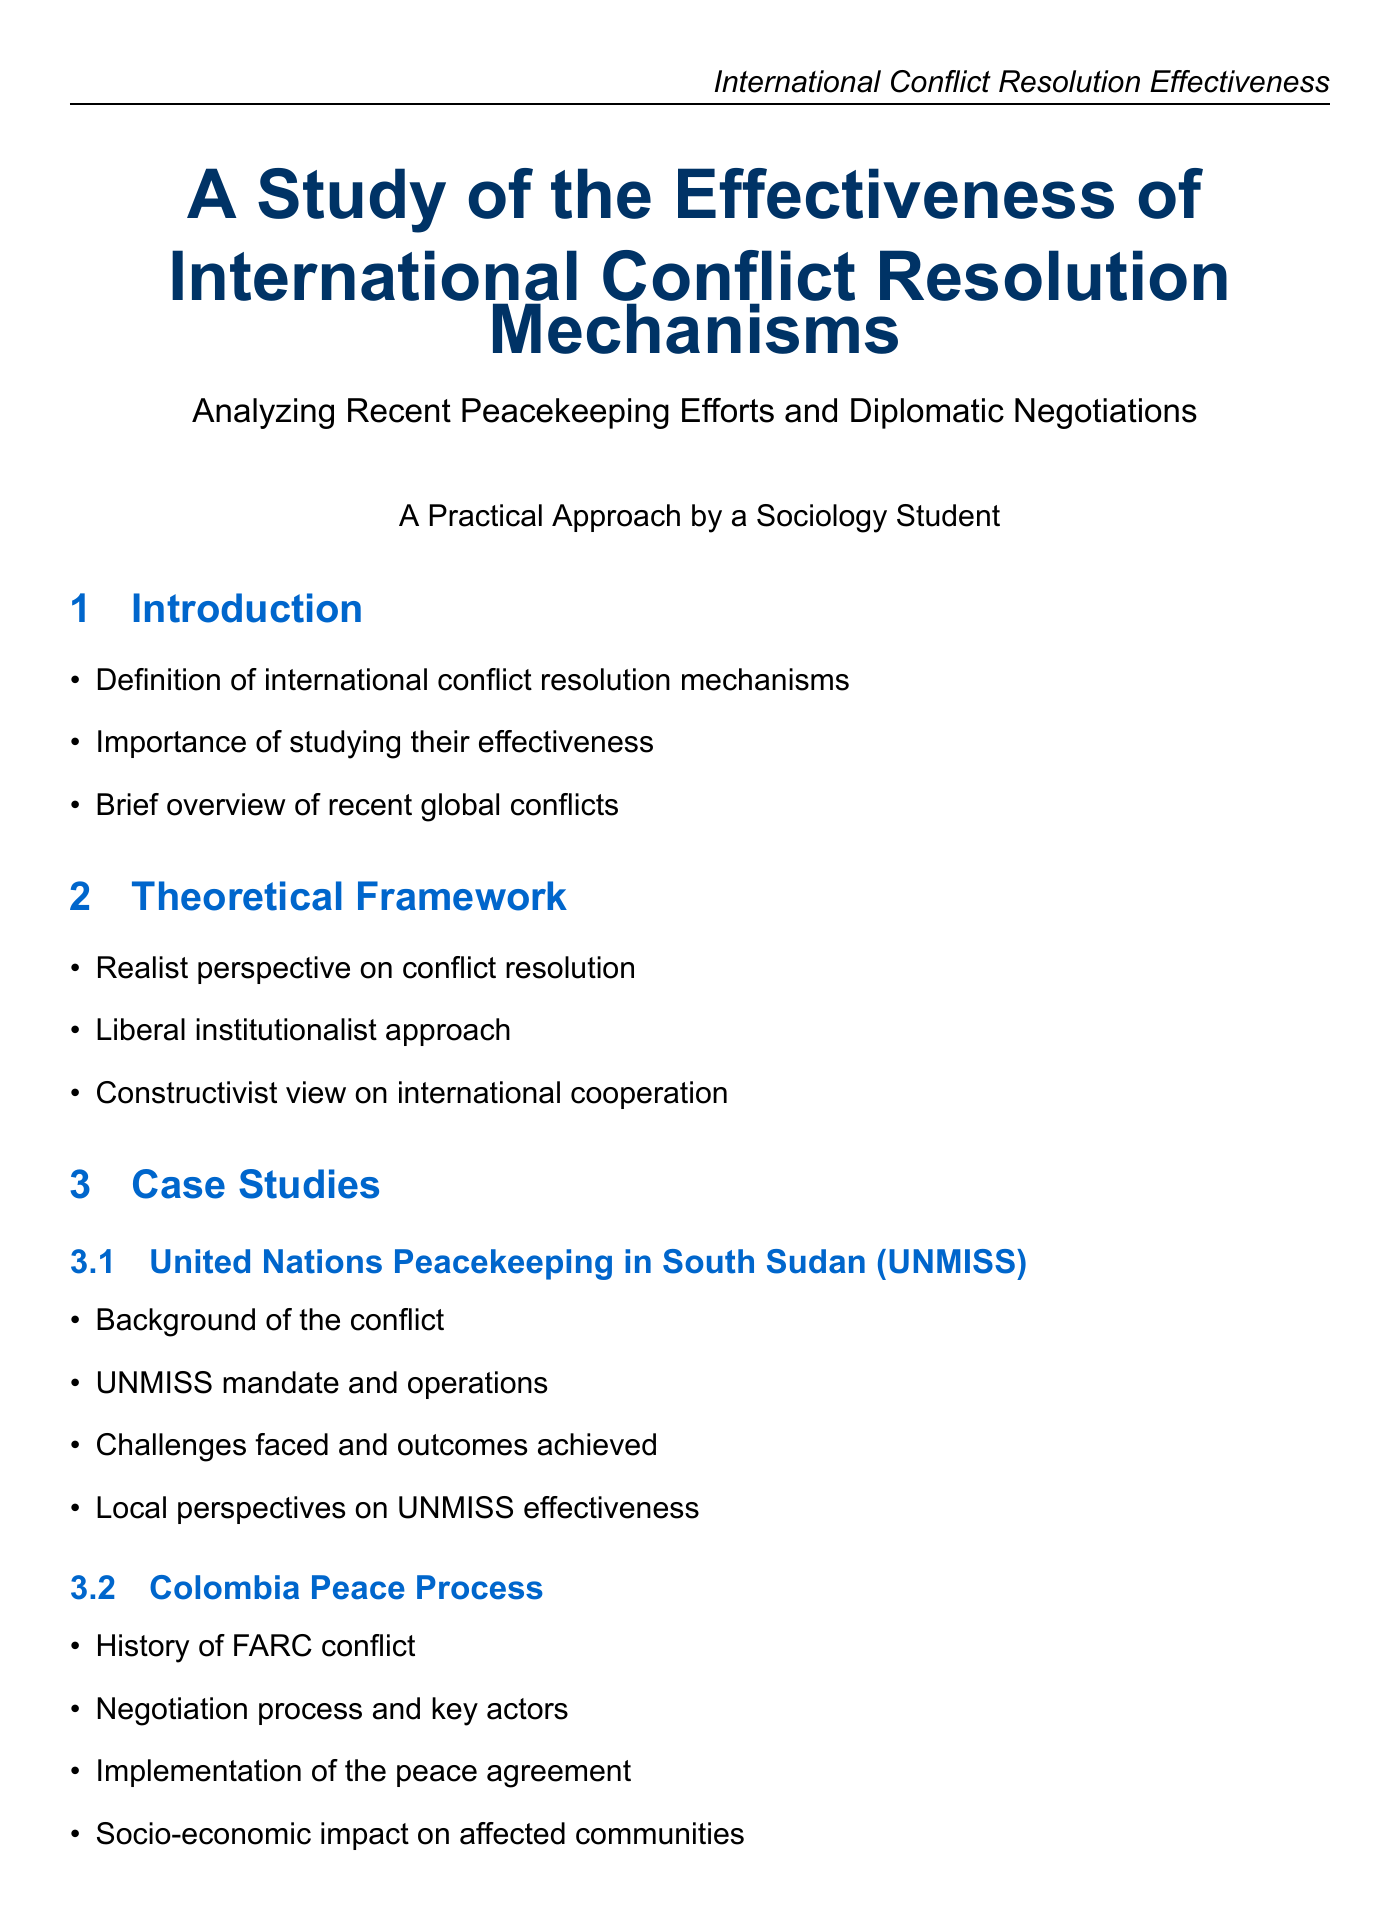What is the mandate of UNMISS? The document details the UNMISS mandate and operations within the subsection on United Nations Peacekeeping in South Sudan.
Answer: UNMISS mandate and operations What is the main focus of the Colombian Peace Process case study? The case study on Colombia covers several aspects, primarily the negotiation process and key actors involved.
Answer: Negotiation process and key actors Which perspective emphasizes collaboration in international relations? Theoretical frameworks mentioned include various perspectives, one of which is focused on international cooperation.
Answer: Constructivist view What year was the report "Why Peace Fails" published? The key sources section provides publication years, indicating the specific year of release for this report.
Answer: 2012 What are the recommended best practices in conflict resolution? The practical implications section highlights various recommendations, including the importance of local ownership.
Answer: Local ownership and cultural sensitivity What organization is mentioned as playing a role in conflict resolution? The analysis section indicates the involvement of various regional organizations in conflict resolution.
Answer: African Union How many case studies are analyzed in the report? The case studies section lists three separate case studies, indicating the total number analyzed.
Answer: Three What is the geographical focus of the field research opportunities? The field research opportunities presented in the document specify locations for potential fieldwork.
Answer: Juba, South Sudan and Bogotá, Colombia 